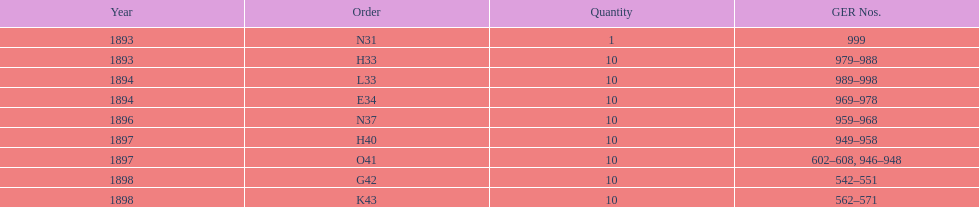Which year lacked an order between 1893 and 1898? 1895. 